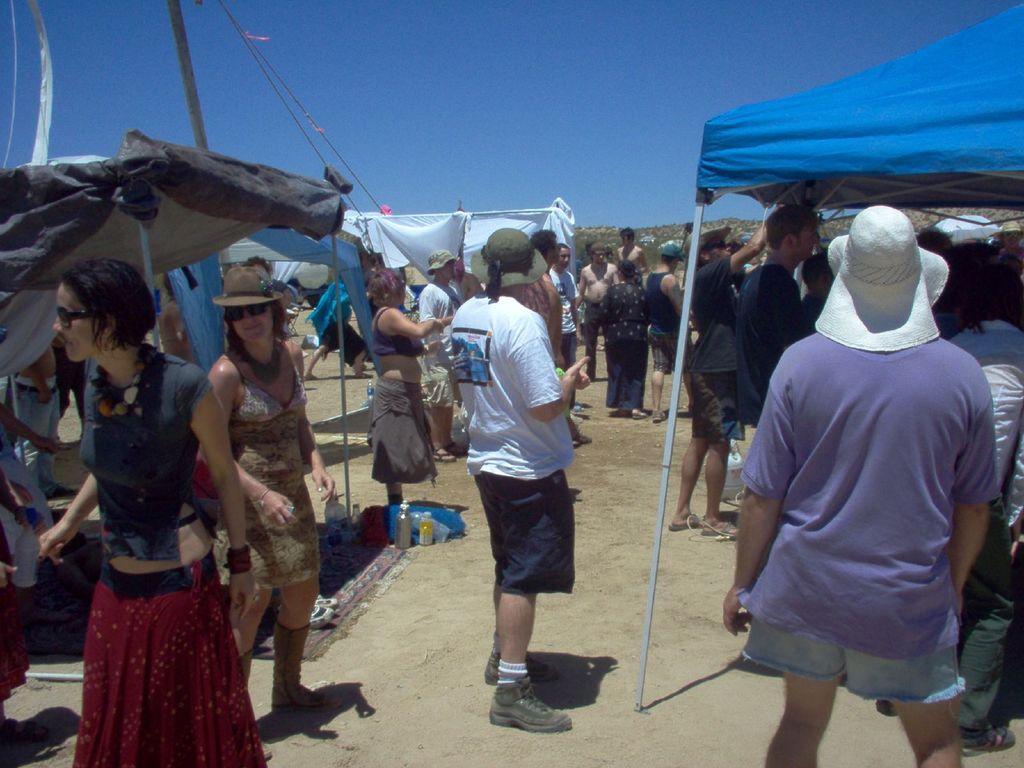How would you summarize this image in a sentence or two? This picture is clicked outside. In the center we can see the group of people standing on the ground and there are some objects placed on the ground and we can see the tents of different colors. In the background there is a sky and the some other objects. 